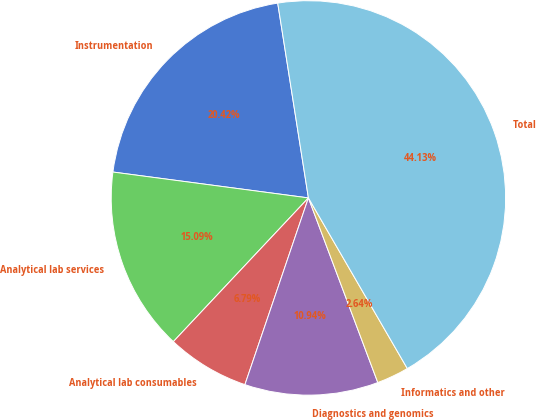<chart> <loc_0><loc_0><loc_500><loc_500><pie_chart><fcel>Instrumentation<fcel>Analytical lab services<fcel>Analytical lab consumables<fcel>Diagnostics and genomics<fcel>Informatics and other<fcel>Total<nl><fcel>20.42%<fcel>15.09%<fcel>6.79%<fcel>10.94%<fcel>2.64%<fcel>44.13%<nl></chart> 